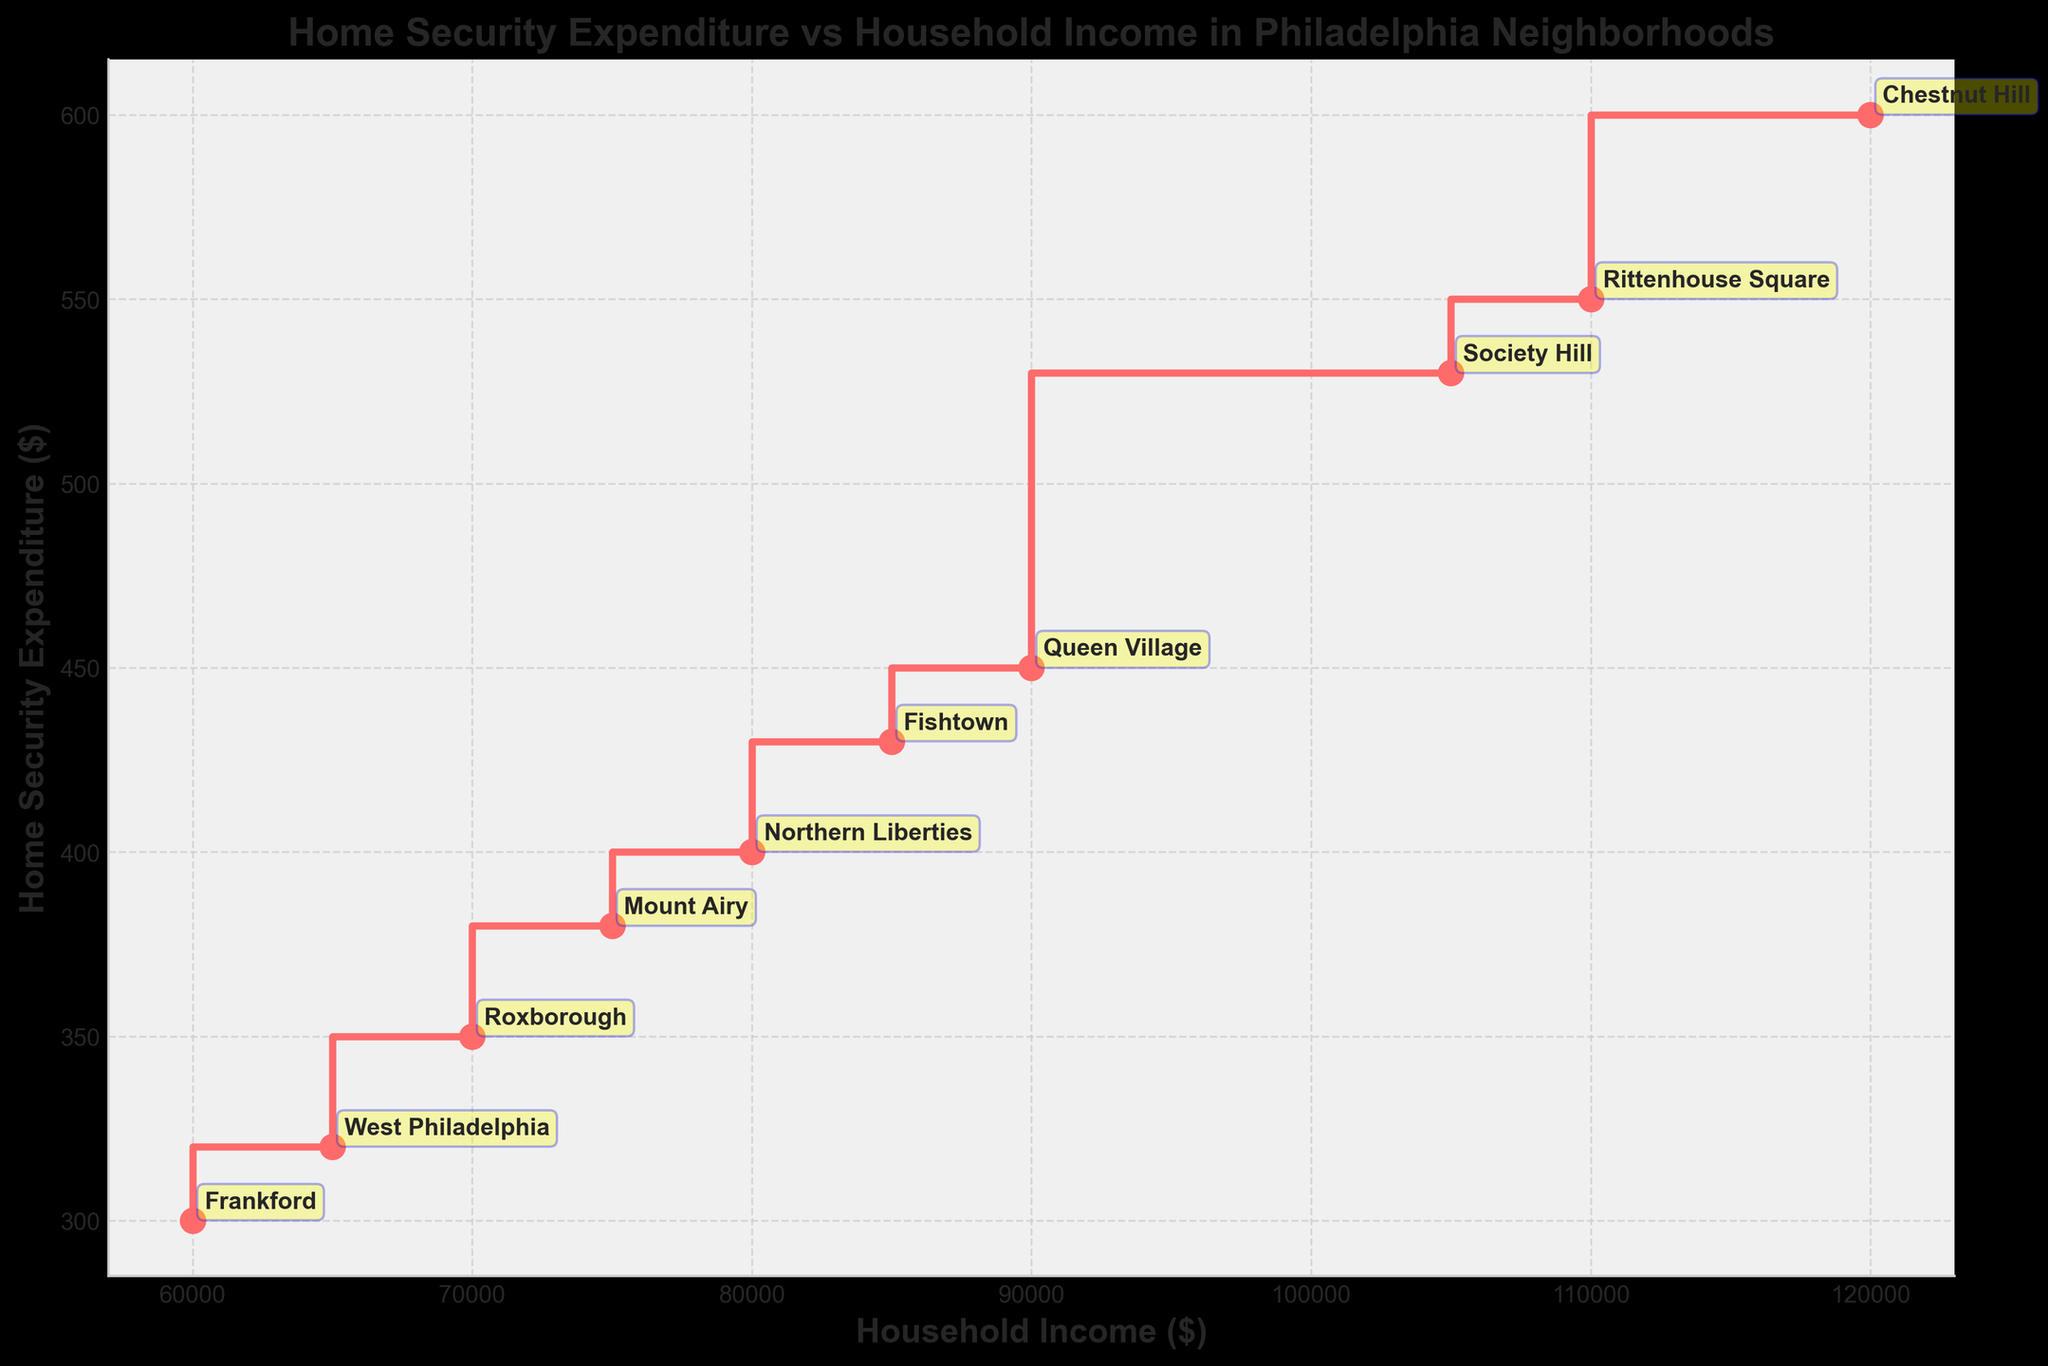How many neighborhoods are represented in the plot? There are 10 different data points in the plot, each representing a neighborhood. By counting the annotations, we see 10 neighborhoods.
Answer: 10 Which neighborhood has the highest household income? The plot shows the household income on the x-axis. The farthest right point represents Chestnut Hill with an income of $120,000.
Answer: Chestnut Hill Which neighborhood has the lowest home security expenditure? The plot shows home security expenditure on the y-axis. The lowest point on this axis represents Frankford with an expenditure of $300.
Answer: Frankford Is there a neighborhood where the household income increases significantly compared to the previous neighborhood? Yes, from Northern Liberties ($80,000) to Queen Village ($90,000), there is a noticeable increase of $10,000.
Answer: Yes How much does the home security expenditure vary across the neighborhoods? The highest expenditure is $600 (Chestnut Hill) and the lowest is $300 (Frankford). The difference is $600 - $300 = $300.
Answer: $300 Considering West Philadelphia and Frankford, which has a higher home security expenditure and by how much? West Philadelphia's expenditure is $320 and Frankford's is $300. The difference is $320 - $300 = $20.
Answer: West Philadelphia by $20 Which neighborhood has the highest home security expenditure with less than $100,000 household income? Fishtown shows a household income of $85,000 and a corresponding security expenditure of $430, which is the highest among neighborhoods with median income less than $100,000.
Answer: Fishtown Are there neighborhoods with the same expenditure on home security? No, all data points on the y-axis are unique and none of the security expenditures are repeated.
Answer: No What's the average household income for neighborhoods that spend more than $500 on home security? The only neighborhoods spending more than $500 are Chestnut Hill ($120,000) and Rittenhouse Square ($110,000). Their average income is ($120,000 + $110,000) / 2 = $115,000.
Answer: $115,000 Is there a direct correlation between household income and home security expenditure in this plot? Generally, higher household income tends to show higher home security expenditure, indicating a positive correlation.
Answer: Yes 